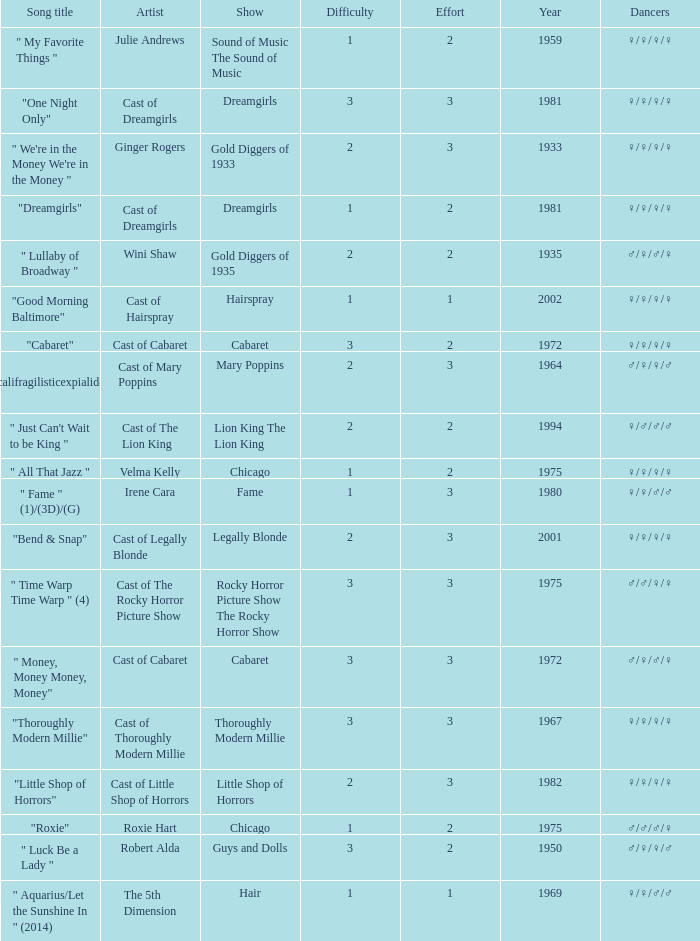Parse the table in full. {'header': ['Song title', 'Artist', 'Show', 'Difficulty', 'Effort', 'Year', 'Dancers'], 'rows': [['" My Favorite Things "', 'Julie Andrews', 'Sound of Music The Sound of Music', '1', '2', '1959', '♀/♀/♀/♀'], ['"One Night Only"', 'Cast of Dreamgirls', 'Dreamgirls', '3', '3', '1981', '♀/♀/♀/♀'], ['" We\'re in the Money We\'re in the Money "', 'Ginger Rogers', 'Gold Diggers of 1933', '2', '3', '1933', '♀/♀/♀/♀'], ['"Dreamgirls"', 'Cast of Dreamgirls', 'Dreamgirls', '1', '2', '1981', '♀/♀/♀/♀'], ['" Lullaby of Broadway "', 'Wini Shaw', 'Gold Diggers of 1935', '2', '2', '1935', '♂/♀/♂/♀'], ['"Good Morning Baltimore"', 'Cast of Hairspray', 'Hairspray', '1', '1', '2002', '♀/♀/♀/♀'], ['"Cabaret"', 'Cast of Cabaret', 'Cabaret', '3', '2', '1972', '♀/♀/♀/♀'], ['" Supercalifragilisticexpialidocious " (DP)', 'Cast of Mary Poppins', 'Mary Poppins', '2', '3', '1964', '♂/♀/♀/♂'], ['" Just Can\'t Wait to be King "', 'Cast of The Lion King', 'Lion King The Lion King', '2', '2', '1994', '♀/♂/♂/♂'], ['" All That Jazz "', 'Velma Kelly', 'Chicago', '1', '2', '1975', '♀/♀/♀/♀'], ['" Fame " (1)/(3D)/(G)', 'Irene Cara', 'Fame', '1', '3', '1980', '♀/♀/♂/♂'], ['"Bend & Snap"', 'Cast of Legally Blonde', 'Legally Blonde', '2', '3', '2001', '♀/♀/♀/♀'], ['" Time Warp Time Warp " (4)', 'Cast of The Rocky Horror Picture Show', 'Rocky Horror Picture Show The Rocky Horror Show', '3', '3', '1975', '♂/♂/♀/♀'], ['" Money, Money Money, Money"', 'Cast of Cabaret', 'Cabaret', '3', '3', '1972', '♂/♀/♂/♀'], ['"Thoroughly Modern Millie"', 'Cast of Thoroughly Modern Millie', 'Thoroughly Modern Millie', '3', '3', '1967', '♀/♀/♀/♀'], ['"Little Shop of Horrors"', 'Cast of Little Shop of Horrors', 'Little Shop of Horrors', '2', '3', '1982', '♀/♀/♀/♀'], ['"Roxie"', 'Roxie Hart', 'Chicago', '1', '2', '1975', '♂/♂/♂/♀'], ['" Luck Be a Lady "', 'Robert Alda', 'Guys and Dolls', '3', '2', '1950', '♂/♀/♀/♂'], ['" Aquarius/Let the Sunshine In " (2014)', 'The 5th Dimension', 'Hair', '1', '1', '1969', '♀/♀/♂/♂']]} How many artists were there for the show thoroughly modern millie? 1.0. 